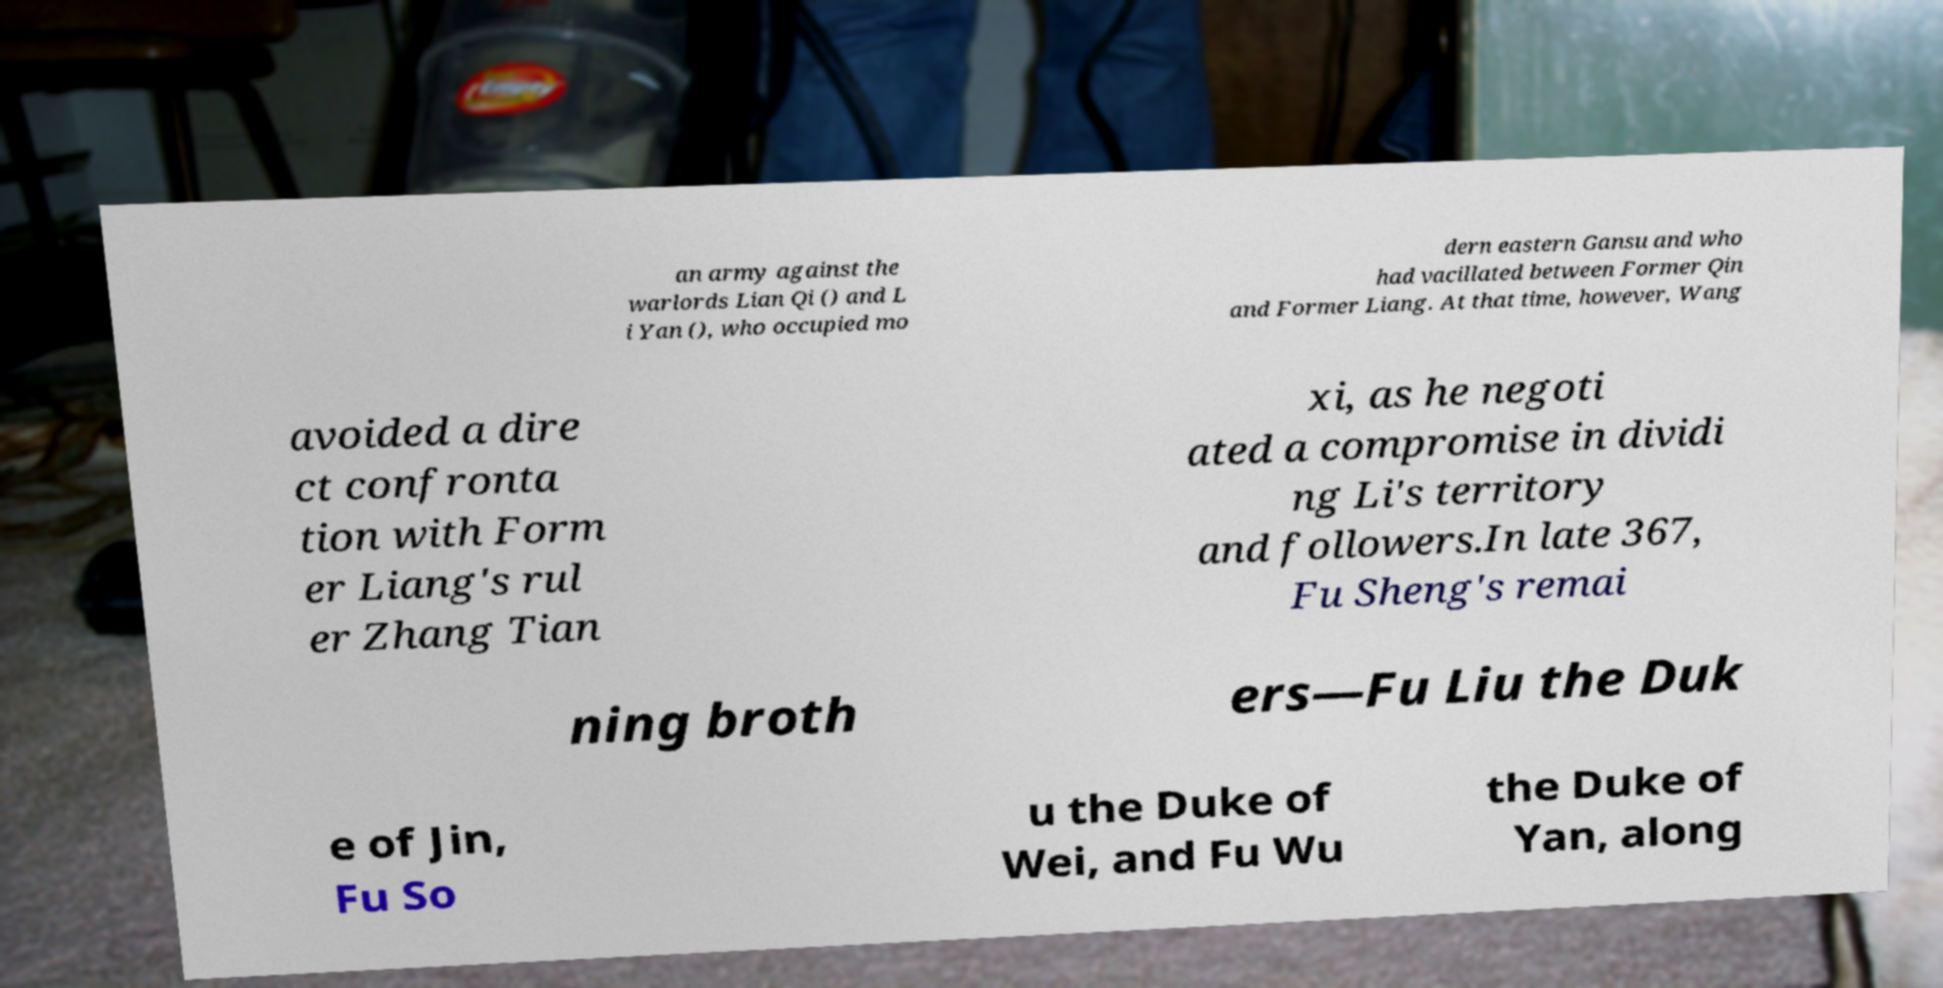There's text embedded in this image that I need extracted. Can you transcribe it verbatim? an army against the warlords Lian Qi () and L i Yan (), who occupied mo dern eastern Gansu and who had vacillated between Former Qin and Former Liang. At that time, however, Wang avoided a dire ct confronta tion with Form er Liang's rul er Zhang Tian xi, as he negoti ated a compromise in dividi ng Li's territory and followers.In late 367, Fu Sheng's remai ning broth ers—Fu Liu the Duk e of Jin, Fu So u the Duke of Wei, and Fu Wu the Duke of Yan, along 